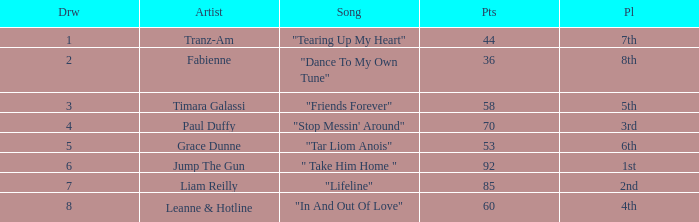What's the highest draw with over 60 points for paul duffy? 4.0. 